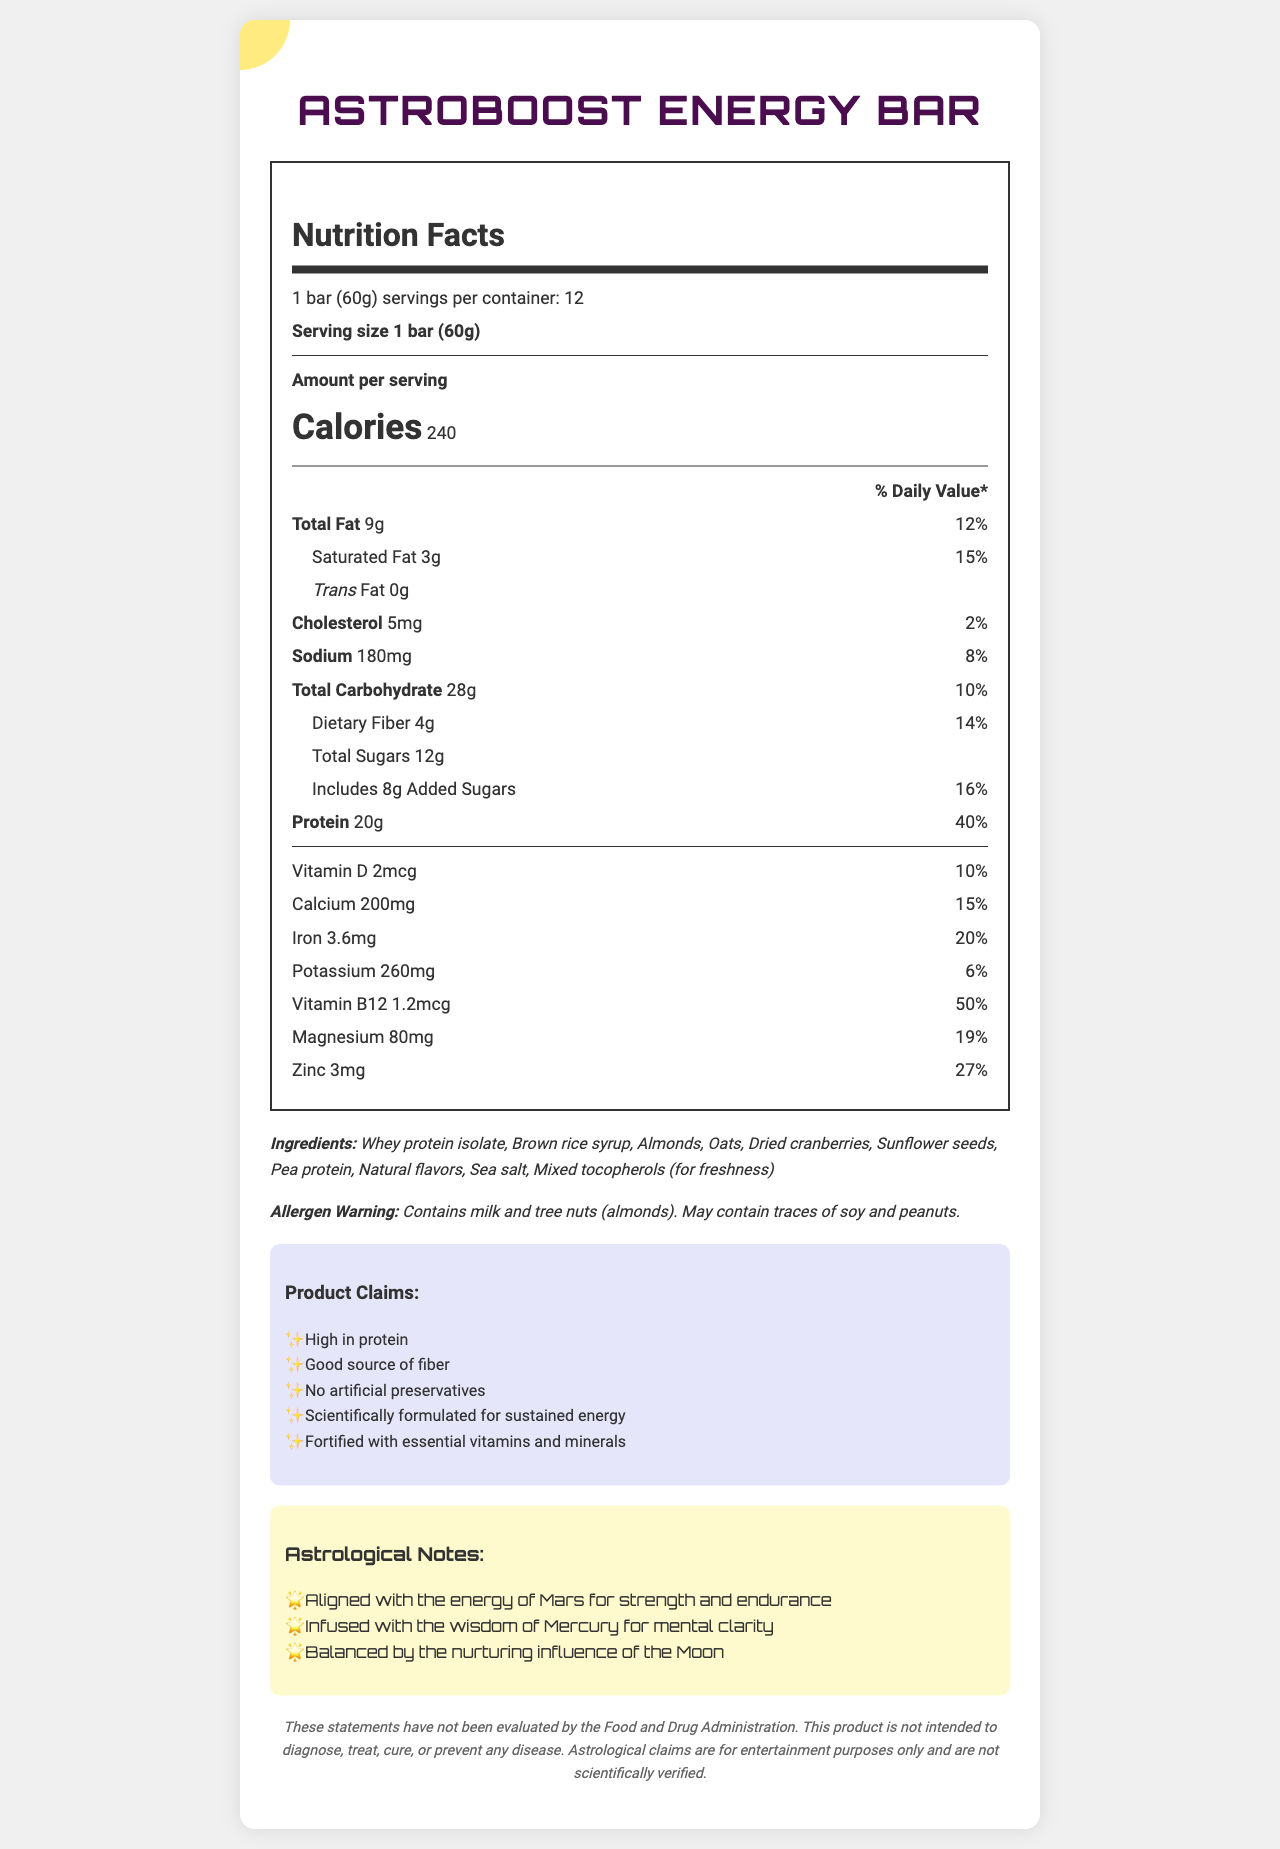what is the product name? The product name is listed at the top of the document.
Answer: AstroBoost Energy Bar how many servings are in the container? The document states that there are 12 servings per container.
Answer: 12 servings how many calories are in one serving? The document specifies that each serving contains 240 calories.
Answer: 240 calories what is the serving size of the energy bar? The serving size is indicated as 1 bar (60g).
Answer: 1 bar (60g) how much protein is in one serving? The document lists the amount of protein in one serving as 20g.
Answer: 20g what percentage of the daily value of fiber does one serving provide? The daily value percentage for dietary fiber is listed as 14%.
Answer: 14% how much vitamin B12 is in one serving? The amount of vitamin B12 per serving is indicated as 1.2mcg.
Answer: 1.2mcg what is the amount of total carbohydrates in one serving? A. 20g B. 28g C. 32g D. 40g The document states that there are 28g of total carbohydrates in one serving.
Answer: B which ingredient is NOT listed in the ingredients of the energy bar? A. Almonds B. Pea protein C. Peanuts D. Whey protein isolate Peanuts are not listed in the ingredients, though there is an allergen warning for possible traces.
Answer: C is the energy bar free from artificial preservatives? One of the product claims states "No artificial preservatives."
Answer: Yes what type of nuts are present in the energy bar? The ingredient list includes almonds, and the allergen warning mentions tree nuts (almonds).
Answer: Almonds describe the astrological significance mentioned in the document. The astrological notes section provides this detailed description.
Answer: The energy bar is aligned with the energy of Mars for strength and endurance, infused with the wisdom of Mercury for mental clarity, and balanced by the nurturing influence of the Moon. how much cholesterol is in one serving? The document specifies that there are 5mg of cholesterol per serving.
Answer: 5mg is the product intended to diagnose, treat, cure, or prevent any disease? The disclaimer states that the product is not intended to diagnose, treat, cure, or prevent any disease.
Answer: No can you determine the retail price of the energy bar from the document? The document does not provide any information regarding the retail price of the energy bar.
Answer: Cannot be determined 